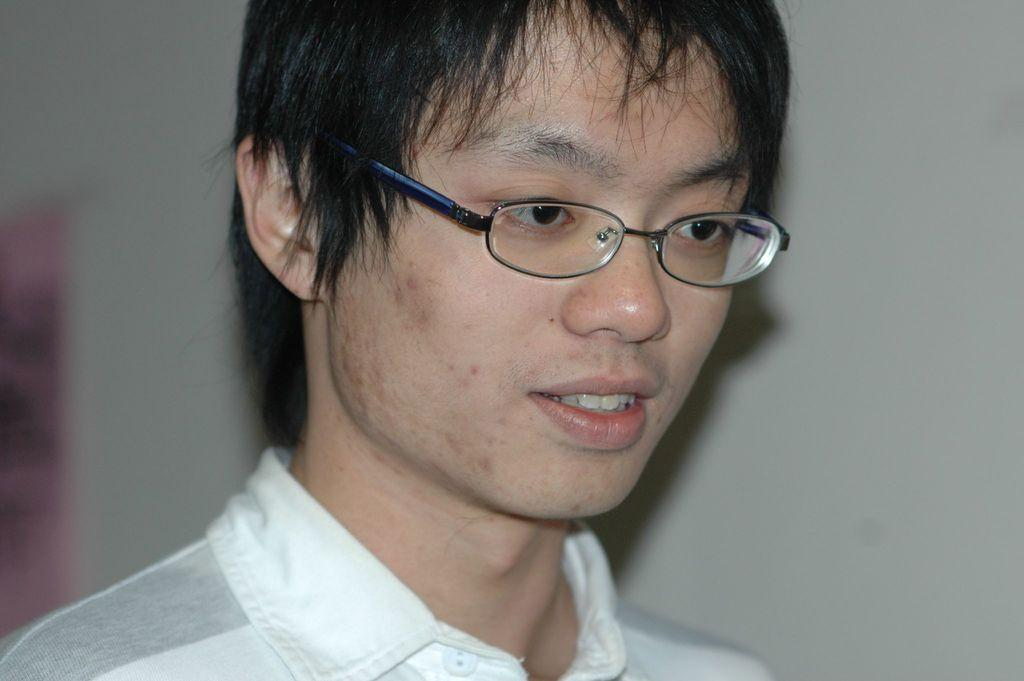Who is present in the image? There is a man in the image. What is the man wearing on his upper body? The man is wearing a white shirt. What accessory is the man wearing on his face? The man is wearing spectacles. Can you describe the background of the image? The background of the image appears blurry. What type of car is the man driving in the image? There is no car present in the image; it only features a man wearing a white shirt and spectacles with a blurry background. 